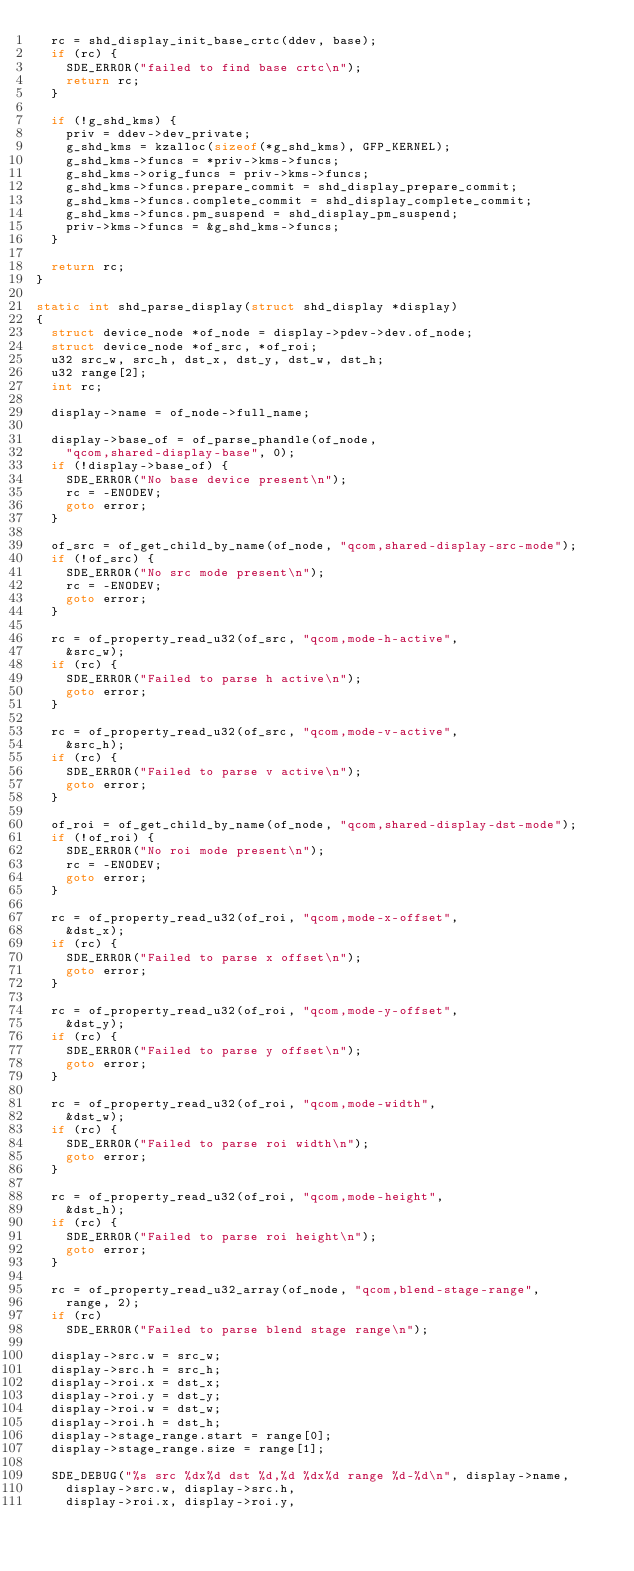<code> <loc_0><loc_0><loc_500><loc_500><_C_>	rc = shd_display_init_base_crtc(ddev, base);
	if (rc) {
		SDE_ERROR("failed to find base crtc\n");
		return rc;
	}

	if (!g_shd_kms) {
		priv = ddev->dev_private;
		g_shd_kms = kzalloc(sizeof(*g_shd_kms), GFP_KERNEL);
		g_shd_kms->funcs = *priv->kms->funcs;
		g_shd_kms->orig_funcs = priv->kms->funcs;
		g_shd_kms->funcs.prepare_commit = shd_display_prepare_commit;
		g_shd_kms->funcs.complete_commit = shd_display_complete_commit;
		g_shd_kms->funcs.pm_suspend = shd_display_pm_suspend;
		priv->kms->funcs = &g_shd_kms->funcs;
	}

	return rc;
}

static int shd_parse_display(struct shd_display *display)
{
	struct device_node *of_node = display->pdev->dev.of_node;
	struct device_node *of_src, *of_roi;
	u32 src_w, src_h, dst_x, dst_y, dst_w, dst_h;
	u32 range[2];
	int rc;

	display->name = of_node->full_name;

	display->base_of = of_parse_phandle(of_node,
		"qcom,shared-display-base", 0);
	if (!display->base_of) {
		SDE_ERROR("No base device present\n");
		rc = -ENODEV;
		goto error;
	}

	of_src = of_get_child_by_name(of_node, "qcom,shared-display-src-mode");
	if (!of_src) {
		SDE_ERROR("No src mode present\n");
		rc = -ENODEV;
		goto error;
	}

	rc = of_property_read_u32(of_src, "qcom,mode-h-active",
		&src_w);
	if (rc) {
		SDE_ERROR("Failed to parse h active\n");
		goto error;
	}

	rc = of_property_read_u32(of_src, "qcom,mode-v-active",
		&src_h);
	if (rc) {
		SDE_ERROR("Failed to parse v active\n");
		goto error;
	}

	of_roi = of_get_child_by_name(of_node, "qcom,shared-display-dst-mode");
	if (!of_roi) {
		SDE_ERROR("No roi mode present\n");
		rc = -ENODEV;
		goto error;
	}

	rc = of_property_read_u32(of_roi, "qcom,mode-x-offset",
		&dst_x);
	if (rc) {
		SDE_ERROR("Failed to parse x offset\n");
		goto error;
	}

	rc = of_property_read_u32(of_roi, "qcom,mode-y-offset",
		&dst_y);
	if (rc) {
		SDE_ERROR("Failed to parse y offset\n");
		goto error;
	}

	rc = of_property_read_u32(of_roi, "qcom,mode-width",
		&dst_w);
	if (rc) {
		SDE_ERROR("Failed to parse roi width\n");
		goto error;
	}

	rc = of_property_read_u32(of_roi, "qcom,mode-height",
		&dst_h);
	if (rc) {
		SDE_ERROR("Failed to parse roi height\n");
		goto error;
	}

	rc = of_property_read_u32_array(of_node, "qcom,blend-stage-range",
		range, 2);
	if (rc)
		SDE_ERROR("Failed to parse blend stage range\n");

	display->src.w = src_w;
	display->src.h = src_h;
	display->roi.x = dst_x;
	display->roi.y = dst_y;
	display->roi.w = dst_w;
	display->roi.h = dst_h;
	display->stage_range.start = range[0];
	display->stage_range.size = range[1];

	SDE_DEBUG("%s src %dx%d dst %d,%d %dx%d range %d-%d\n", display->name,
		display->src.w, display->src.h,
		display->roi.x, display->roi.y,</code> 